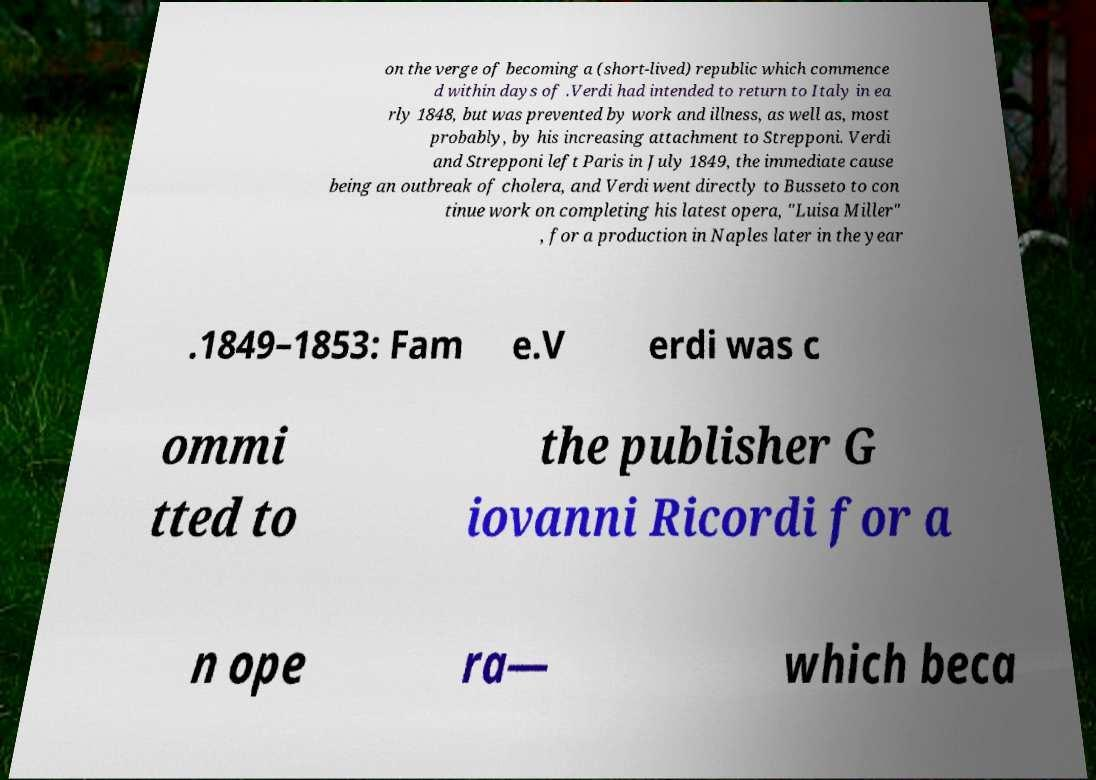Could you assist in decoding the text presented in this image and type it out clearly? on the verge of becoming a (short-lived) republic which commence d within days of .Verdi had intended to return to Italy in ea rly 1848, but was prevented by work and illness, as well as, most probably, by his increasing attachment to Strepponi. Verdi and Strepponi left Paris in July 1849, the immediate cause being an outbreak of cholera, and Verdi went directly to Busseto to con tinue work on completing his latest opera, "Luisa Miller" , for a production in Naples later in the year .1849–1853: Fam e.V erdi was c ommi tted to the publisher G iovanni Ricordi for a n ope ra— which beca 